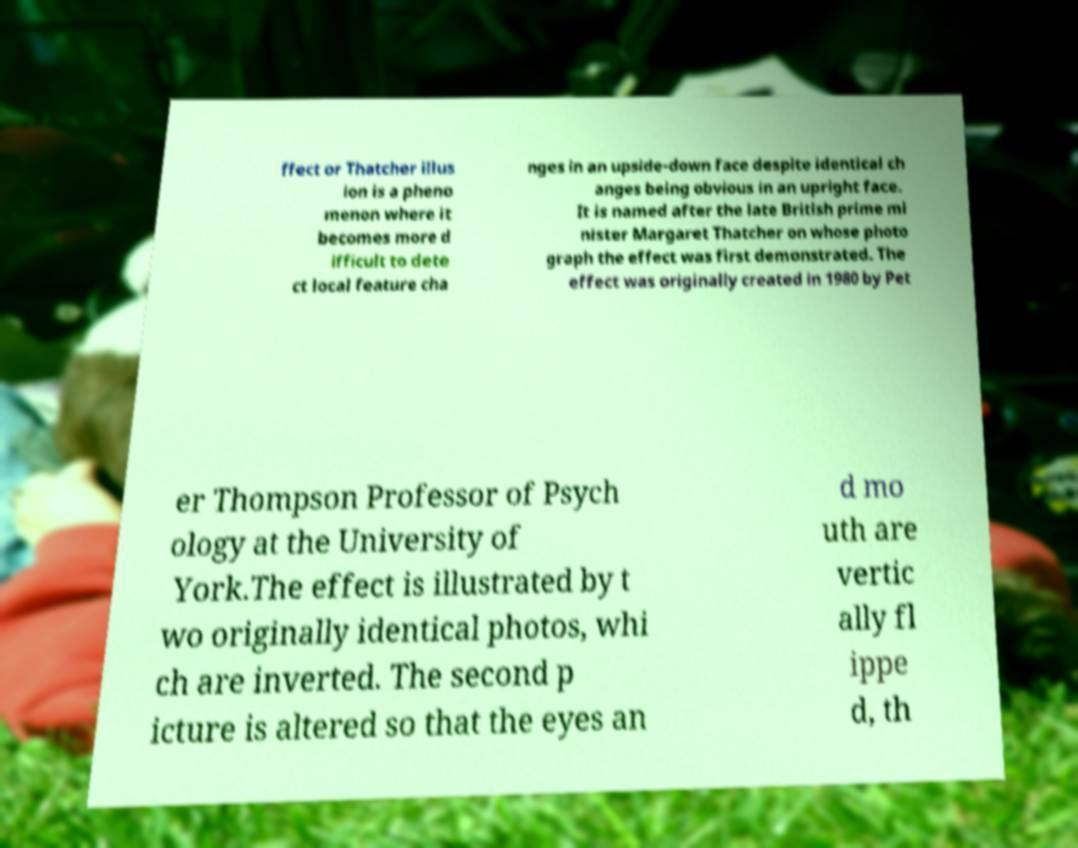What messages or text are displayed in this image? I need them in a readable, typed format. ffect or Thatcher illus ion is a pheno menon where it becomes more d ifficult to dete ct local feature cha nges in an upside-down face despite identical ch anges being obvious in an upright face. It is named after the late British prime mi nister Margaret Thatcher on whose photo graph the effect was first demonstrated. The effect was originally created in 1980 by Pet er Thompson Professor of Psych ology at the University of York.The effect is illustrated by t wo originally identical photos, whi ch are inverted. The second p icture is altered so that the eyes an d mo uth are vertic ally fl ippe d, th 